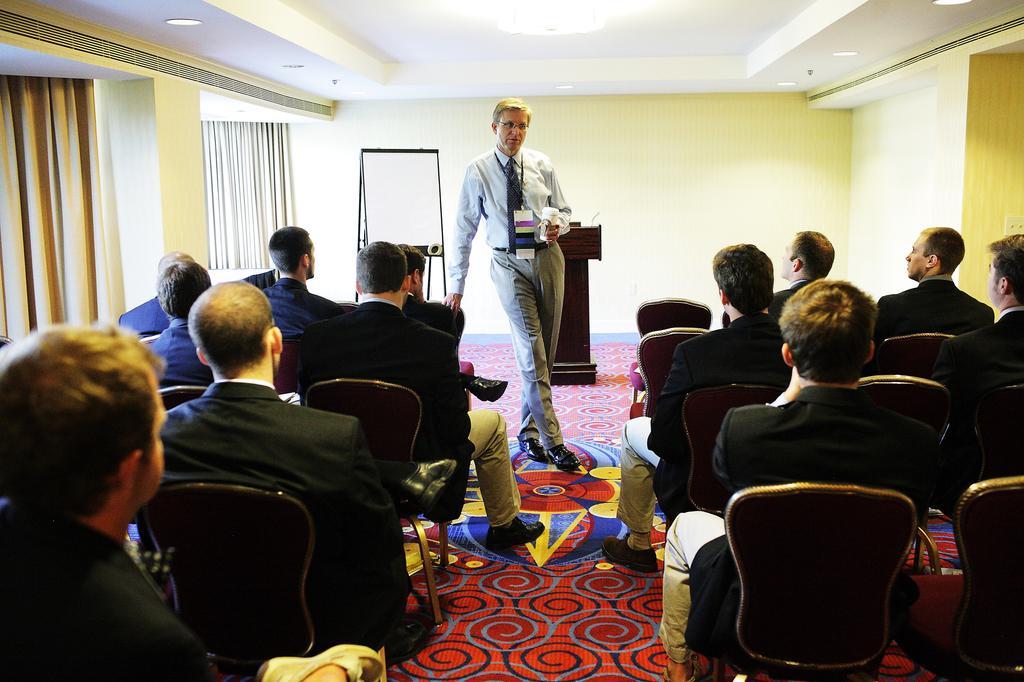How would you summarize this image in a sentence or two? In this picture we can see a group of people sitting on chairs on the floor, one person is standing, he is wearing an id card, holding a glass and in the background we can see a wall, curtains, lights, podium, stand with a board, roof and some objects. 